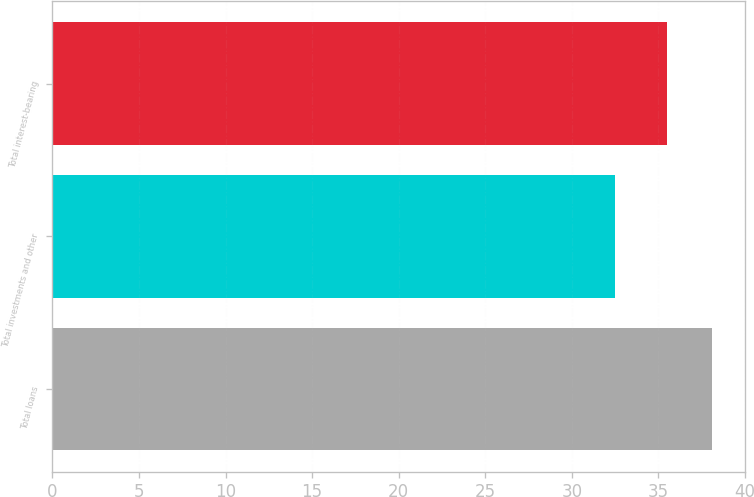<chart> <loc_0><loc_0><loc_500><loc_500><bar_chart><fcel>Total loans<fcel>Total investments and other<fcel>Total interest-bearing<nl><fcel>38.1<fcel>32.5<fcel>35.5<nl></chart> 